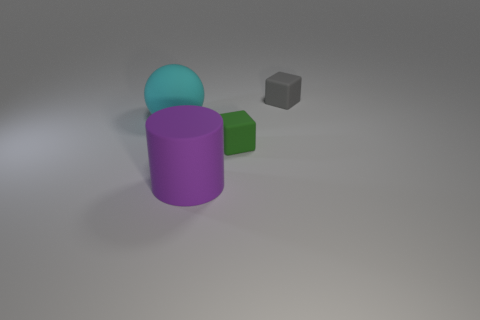How many other things are the same color as the matte cylinder?
Ensure brevity in your answer.  0. How many yellow objects are the same material as the purple cylinder?
Your response must be concise. 0. What number of other objects are the same size as the cyan ball?
Keep it short and to the point. 1. Is there a cyan sphere that has the same size as the gray thing?
Your answer should be very brief. No. Do the rubber block in front of the gray rubber thing and the matte sphere have the same color?
Provide a succinct answer. No. What number of things are either large purple cylinders or large yellow spheres?
Provide a succinct answer. 1. There is a thing to the left of the purple rubber object; does it have the same size as the purple matte cylinder?
Give a very brief answer. Yes. What is the size of the matte object that is both left of the green rubber thing and in front of the ball?
Provide a succinct answer. Large. How many other things are the same shape as the cyan thing?
Offer a terse response. 0. How many other things are there of the same material as the large purple cylinder?
Provide a succinct answer. 3. 